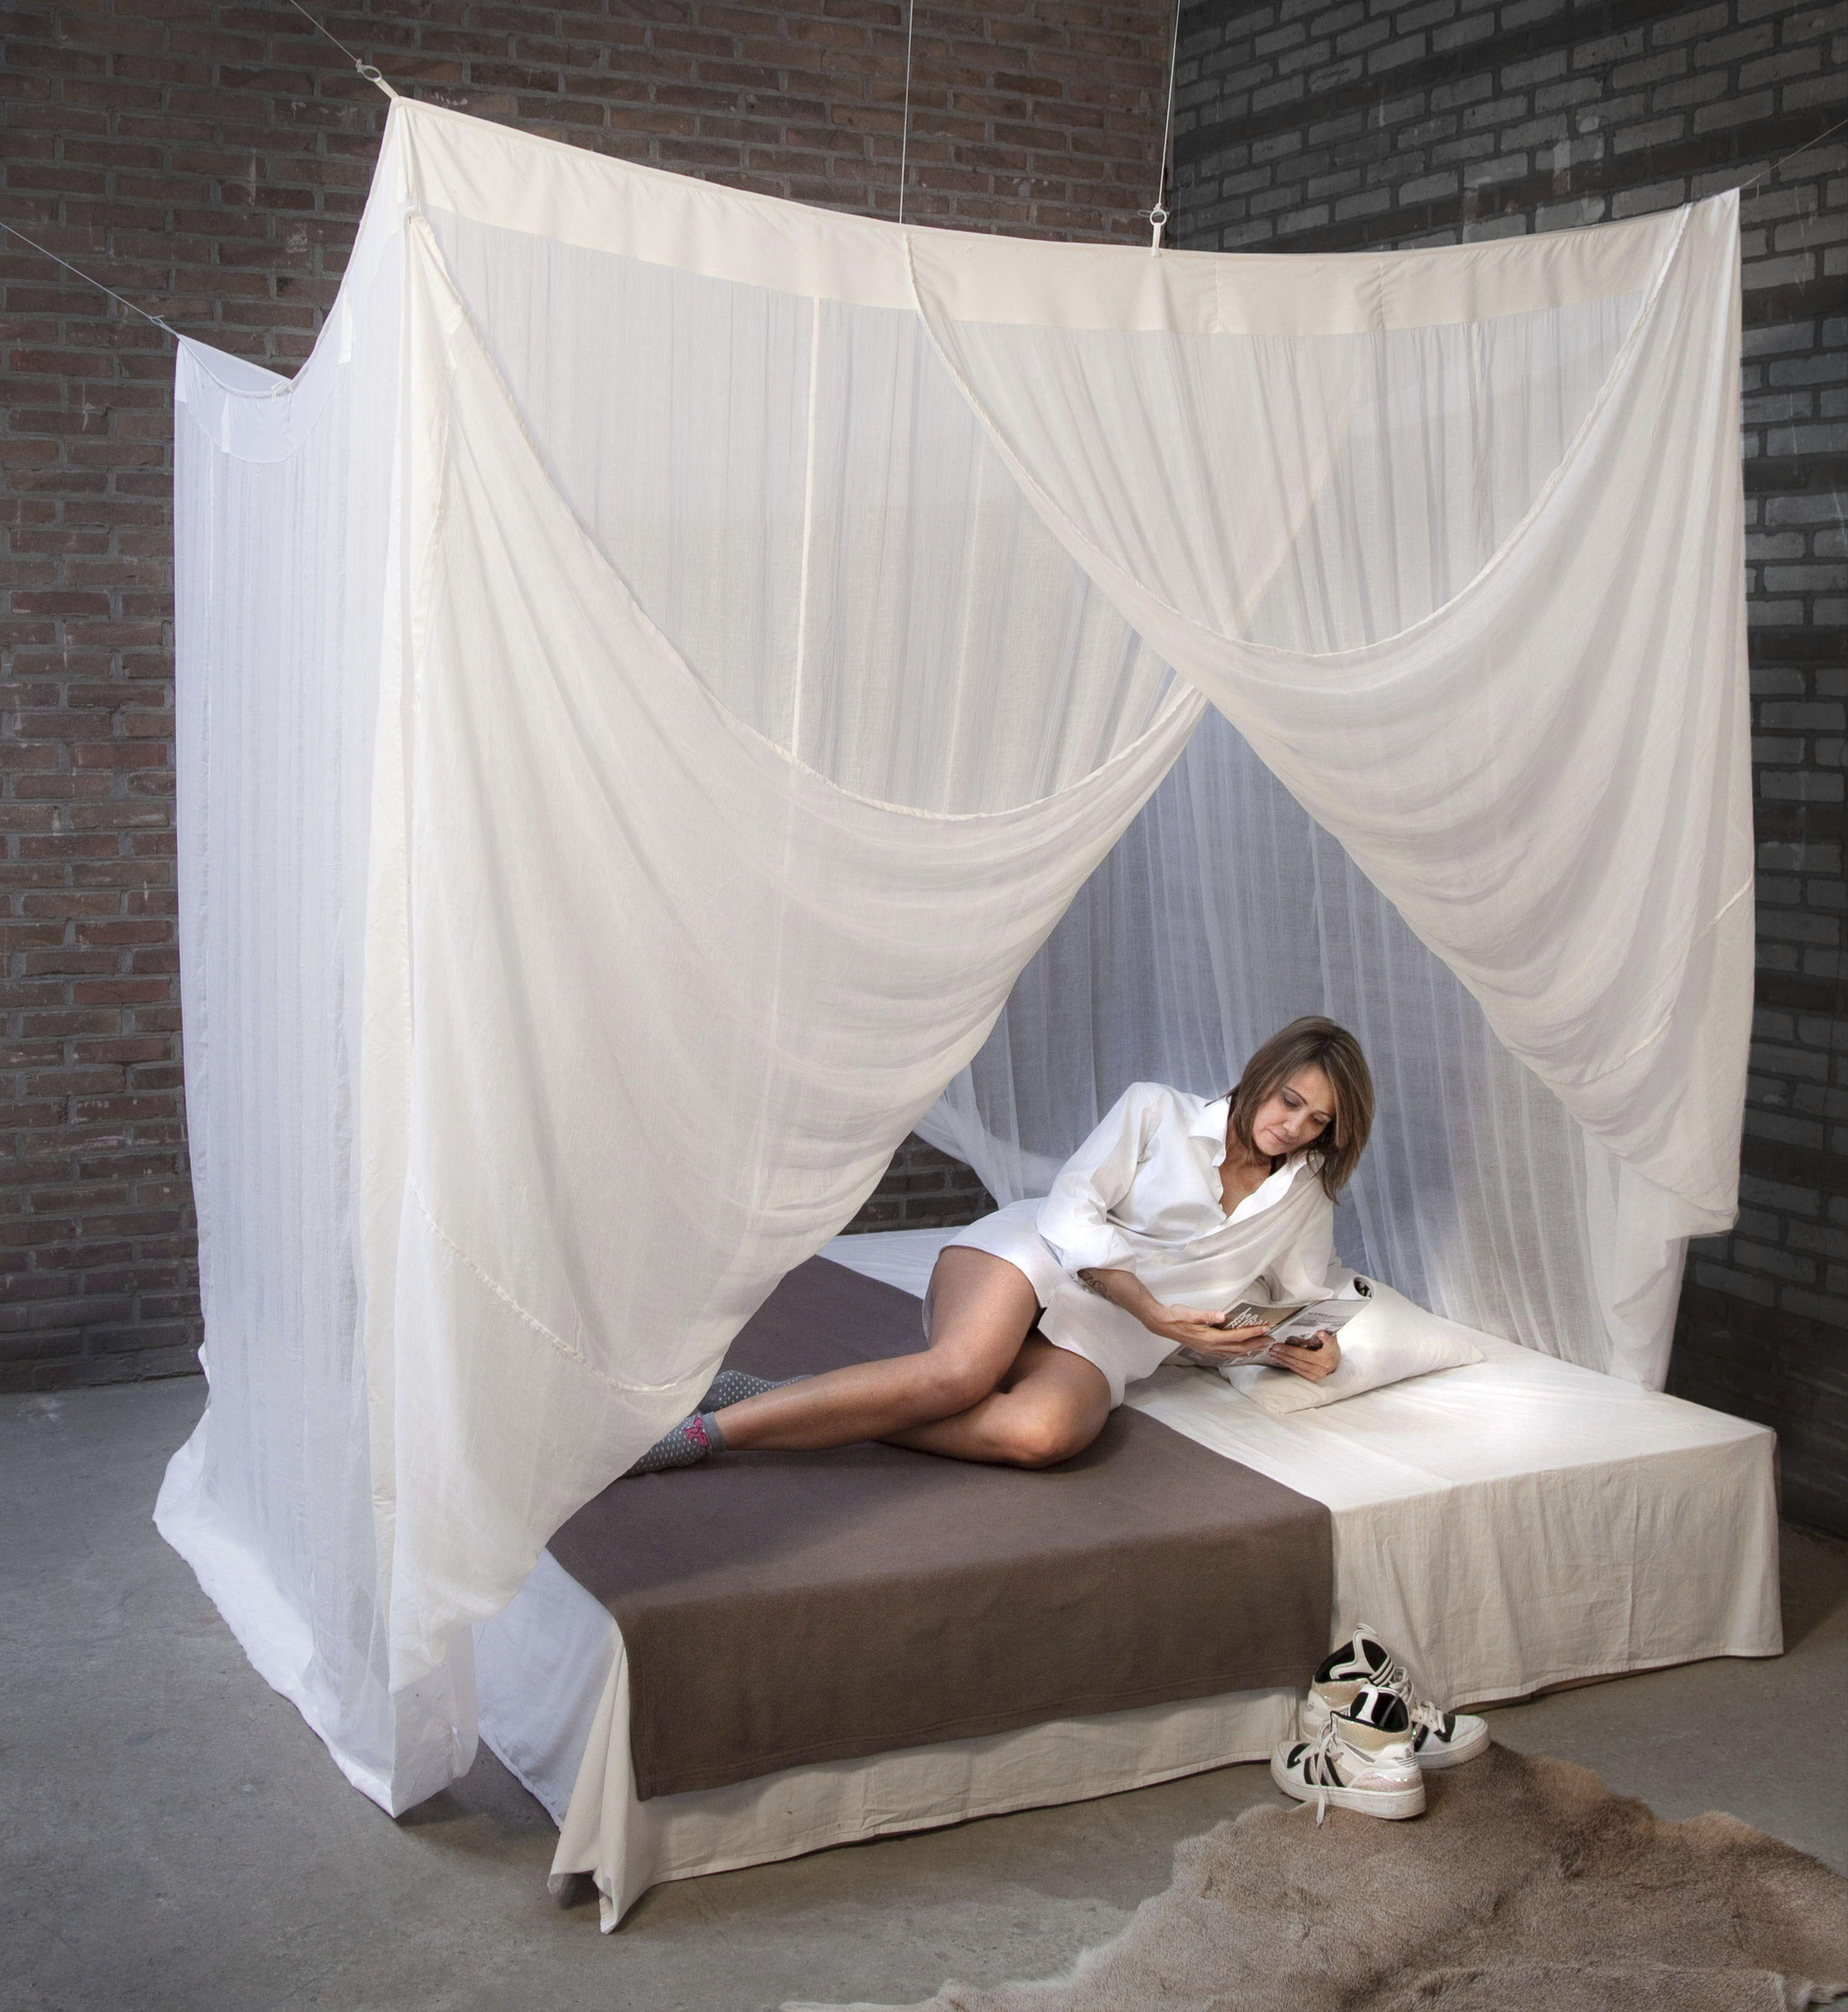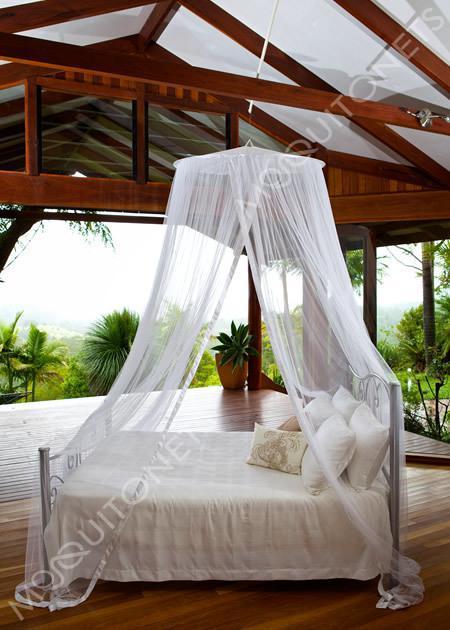The first image is the image on the left, the second image is the image on the right. Analyze the images presented: Is the assertion "The canopy bed in the left image is by a window showing daylight outside." valid? Answer yes or no. No. The first image is the image on the left, the second image is the image on the right. For the images displayed, is the sentence "The bed has a woman laying on the mattress." factually correct? Answer yes or no. Yes. 